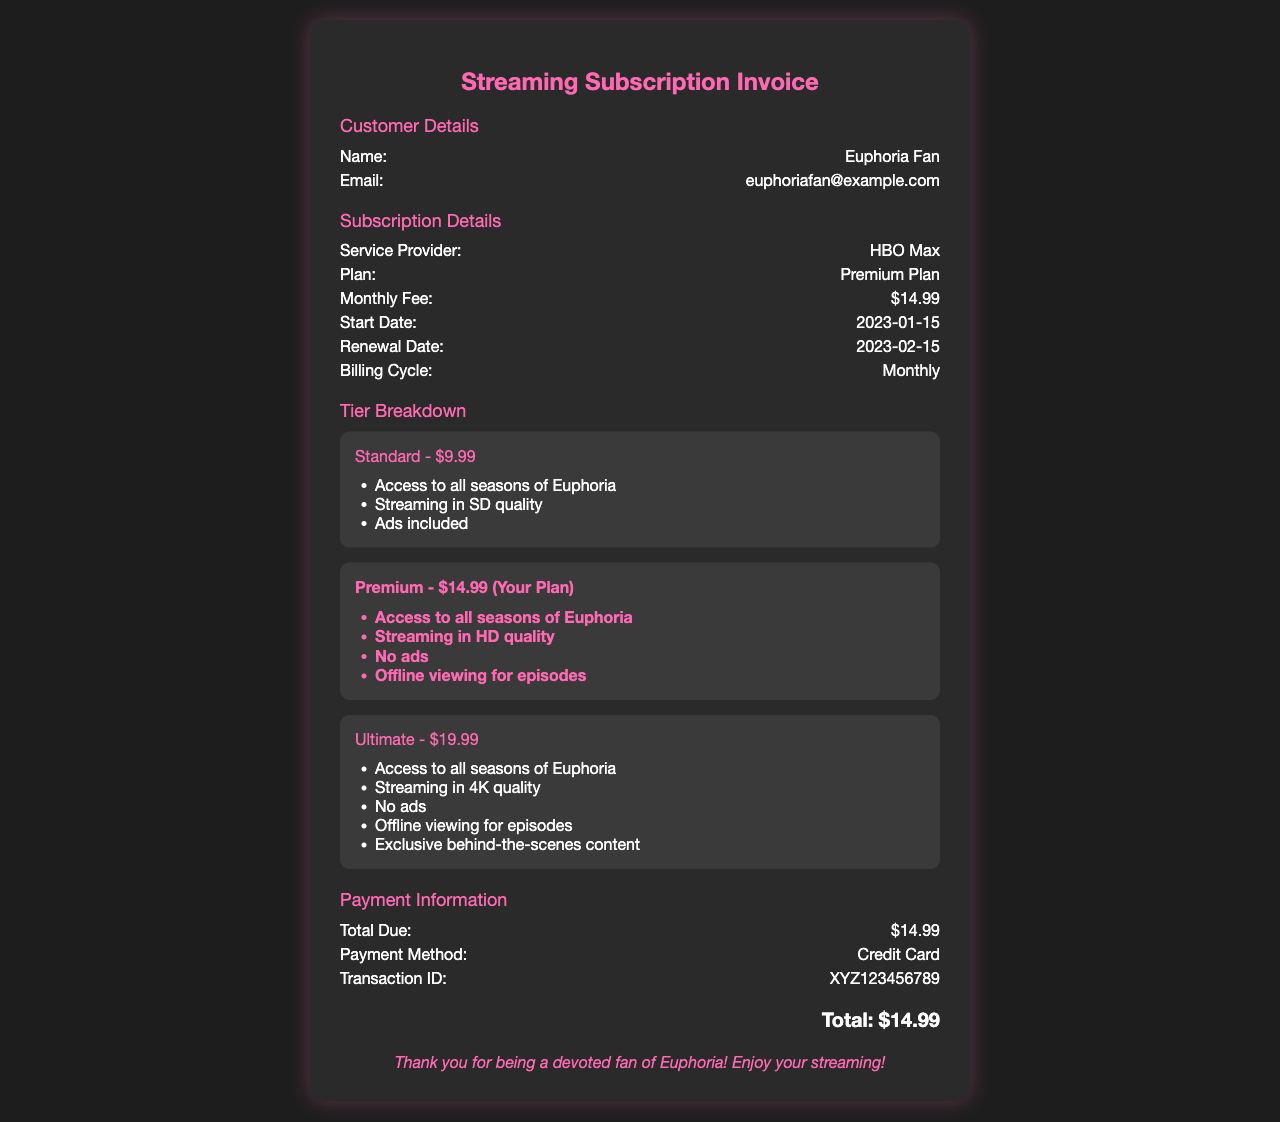What is the customer's name? The customer's name is specified in the document as the individual who received the receipt, which is Euphoria Fan.
Answer: Euphoria Fan What is the service provider? The document states the provider of the streaming service, which is HBO Max.
Answer: HBO Max What is the renewal date of the subscription? The renewal date is indicated in the document, showing when the next payment is due, which is 2023-02-15.
Answer: 2023-02-15 What is the monthly fee for the Premium Plan? The Premium Plan fee is listed in the document as the cost for the subscription service, which is $14.99.
Answer: $14.99 How many tiers are available for the subscription? The document outlines three tiers of subscription plans available for the service.
Answer: Three What features are included in the Premium Plan? To provide more details on the Premium Plan, the document lists specific features included, which helps identify the benefits of this subscription level.
Answer: Access to all seasons of Euphoria, Streaming in HD quality, No ads, Offline viewing for episodes What was the total due this month? The total due amount is specified in the payment information section of the document as the cost for the current billing cycle.
Answer: $14.99 What payment method was used? The document includes the method of payment used for the subscription, which is informative for confirming the transaction details.
Answer: Credit Card What is the transaction ID? The transaction ID serves as a unique identifier for the payment, which can be referenced in future inquiries, and it is clearly stated in the document.
Answer: XYZ123456789 